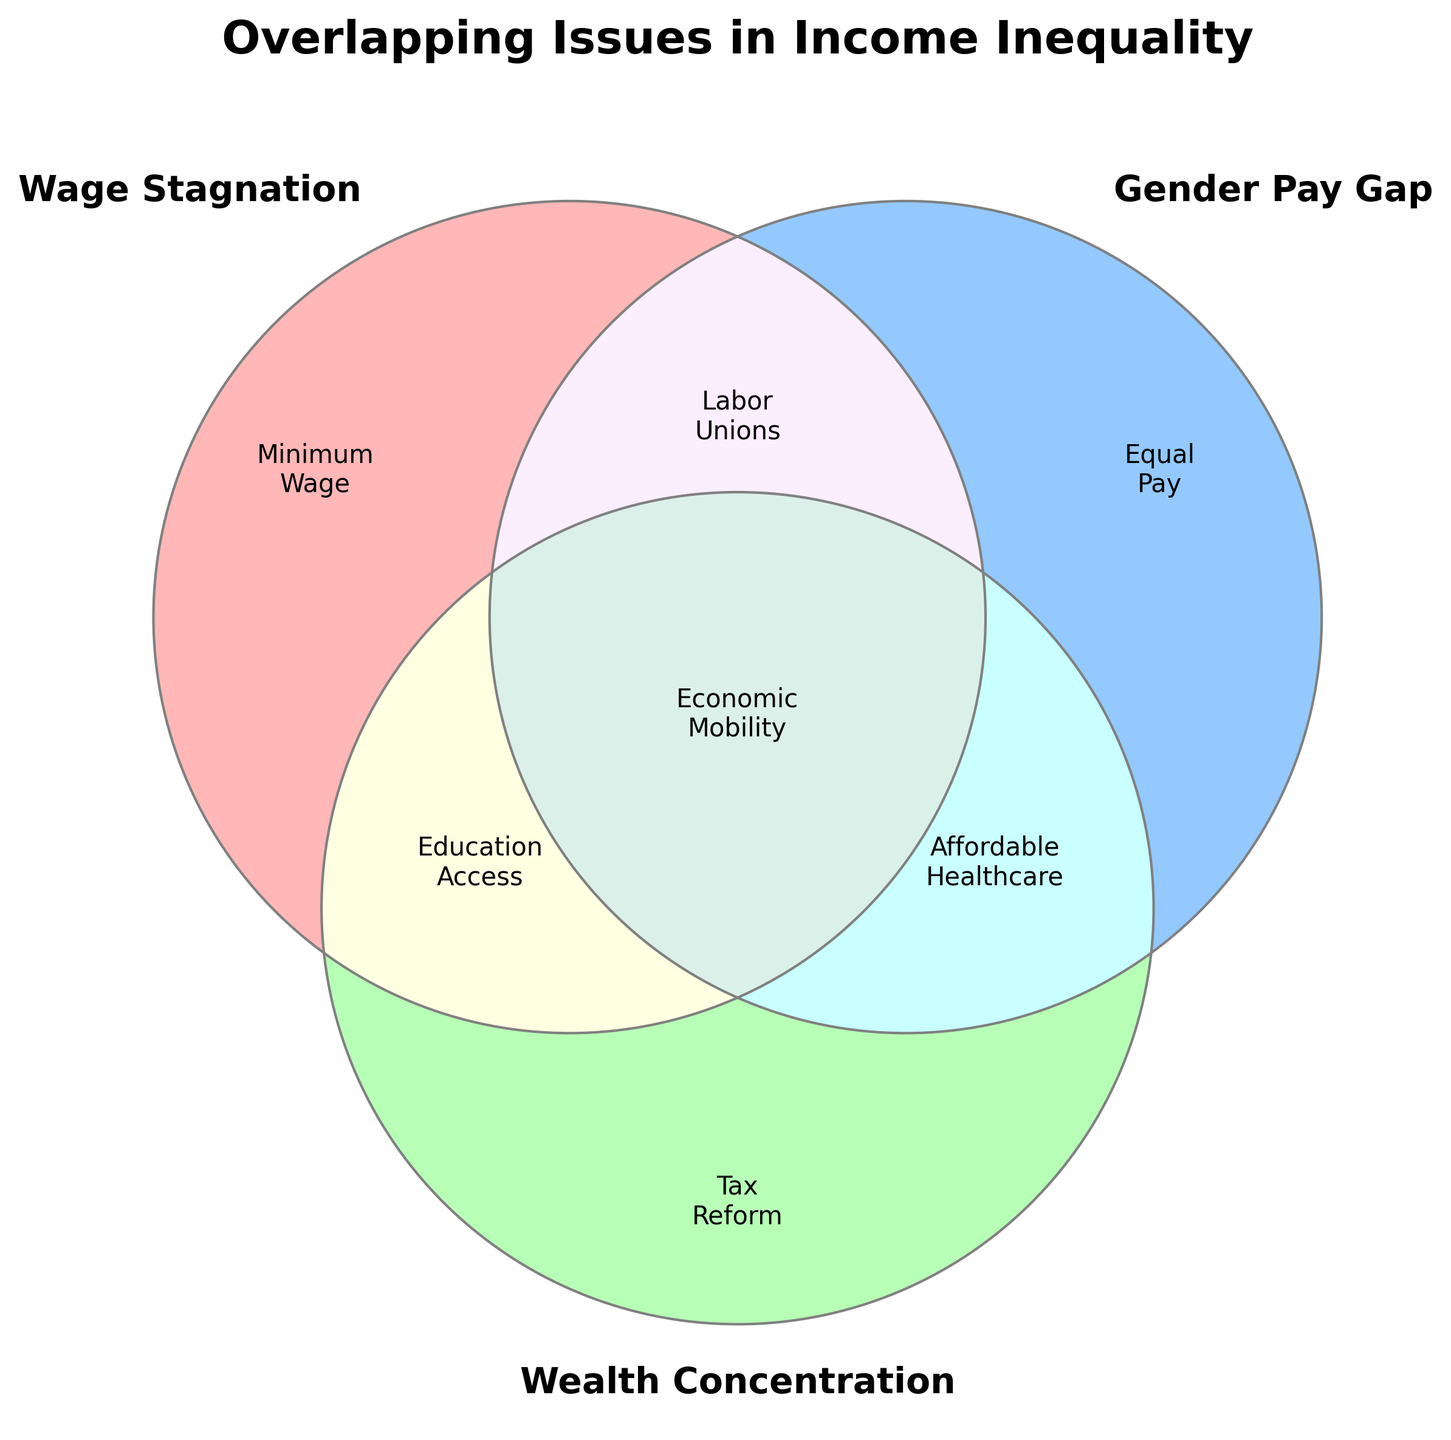What is the title of the figure? The title of the figure is located at the top and clearly labeled in bold text. It reads "Overlapping Issues in Income Inequality."
Answer: Overlapping Issues in Income Inequality Which color represents the 'Gender Pay Gap' set? The 'Gender Pay Gap' set is represented by the circle on the right with a blueish color.
Answer: Blueish Which issue falls in the intersection of all three sets? The intersection of all three sets is represented by the region where all three circles overlap, and the label there is "Economic Mobility."
Answer: Economic Mobility What are the issues represented only by the 'Wage Stagnation' set? The issue in the 'Wage Stagnation' set, without any overlaps with the other sets, is labeled as "Minimum Wage."
Answer: Minimum Wage How many unique issues are labeled in the diagram? We identify one unique issue per region, including all intersections and individual sets. The unique issues indicated in the figure are "Minimum Wage," "Equal Pay," "Tax Reform," "Labor Unions," "Education Access," "Affordable Healthcare," and "Economic Mobility." This totals 7 unique issues.
Answer: 7 Which set contains the issue 'Labor Unions' and what other set is it overlapping with? 'Labor Unions' is found in the overlapping region between 'Wage Stagnation' and 'Gender Pay Gap'. This can be identified by locating the area where 'Wage Stagnation' and 'Gender Pay Gap' circles intersect and observing the label.
Answer: Wage Stagnation and Gender Pay Gap What issue is found in the overlap of 'Gender Pay Gap' and 'Wealth Concentration' but not 'Wage Stagnation'? To find this, look at the intersection between 'Gender Pay Gap' and 'Wealth Concentration' circles but outside the 'Wage Stagnation' circle. The label in that segment reads "Affordable Healthcare."
Answer: Affordable Healthcare Which issue is only related to the 'Wealth Concentration' set? The issue specific to the 'Wealth Concentration' set, without overlaps with the other sets, is labeled as "Tax Reform."
Answer: Tax Reform What's the correlation between 'Wage Stagnation', 'Gender Pay Gap', and 'Wealth Concentration' based on the issues shown? By examining the labels in each overlapping section, one can identify correlations: 'Economic Mobility' relates to all three; 'Labor Unions' connects 'Wage Stagnation' and 'Gender Pay Gap'; 'Education Access' connects 'Wage Stagnation' and 'Wealth Concentration'; 'Affordable Healthcare' connects 'Gender Pay Gap' and 'Wealth Concentration.'
Answer: See Explanation 